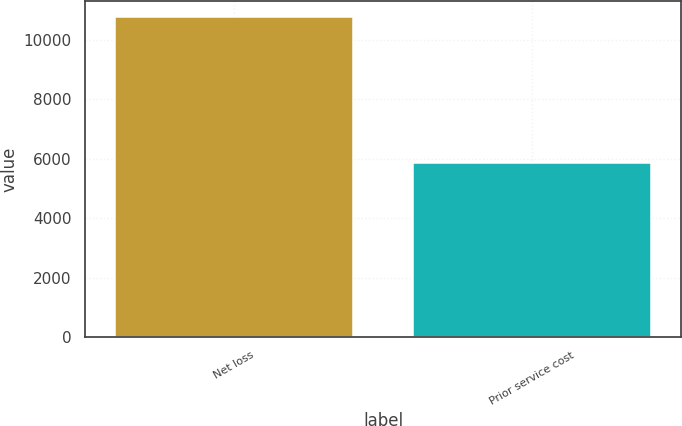Convert chart to OTSL. <chart><loc_0><loc_0><loc_500><loc_500><bar_chart><fcel>Net loss<fcel>Prior service cost<nl><fcel>10763<fcel>5848<nl></chart> 